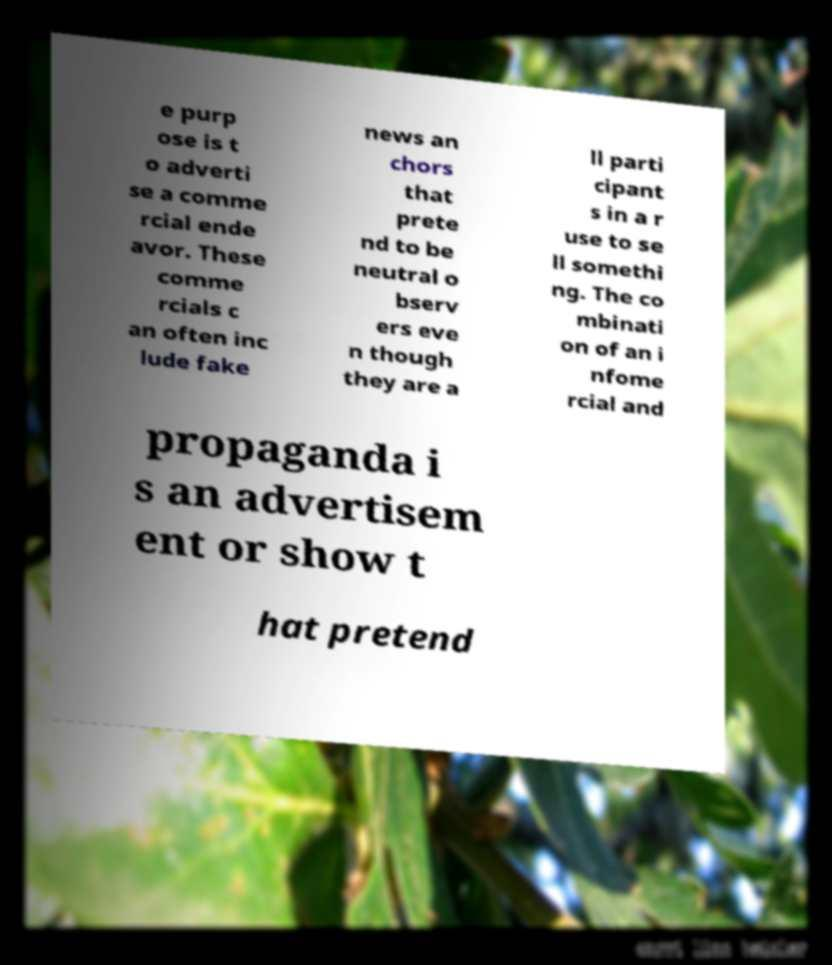Can you read and provide the text displayed in the image?This photo seems to have some interesting text. Can you extract and type it out for me? e purp ose is t o adverti se a comme rcial ende avor. These comme rcials c an often inc lude fake news an chors that prete nd to be neutral o bserv ers eve n though they are a ll parti cipant s in a r use to se ll somethi ng. The co mbinati on of an i nfome rcial and propaganda i s an advertisem ent or show t hat pretend 